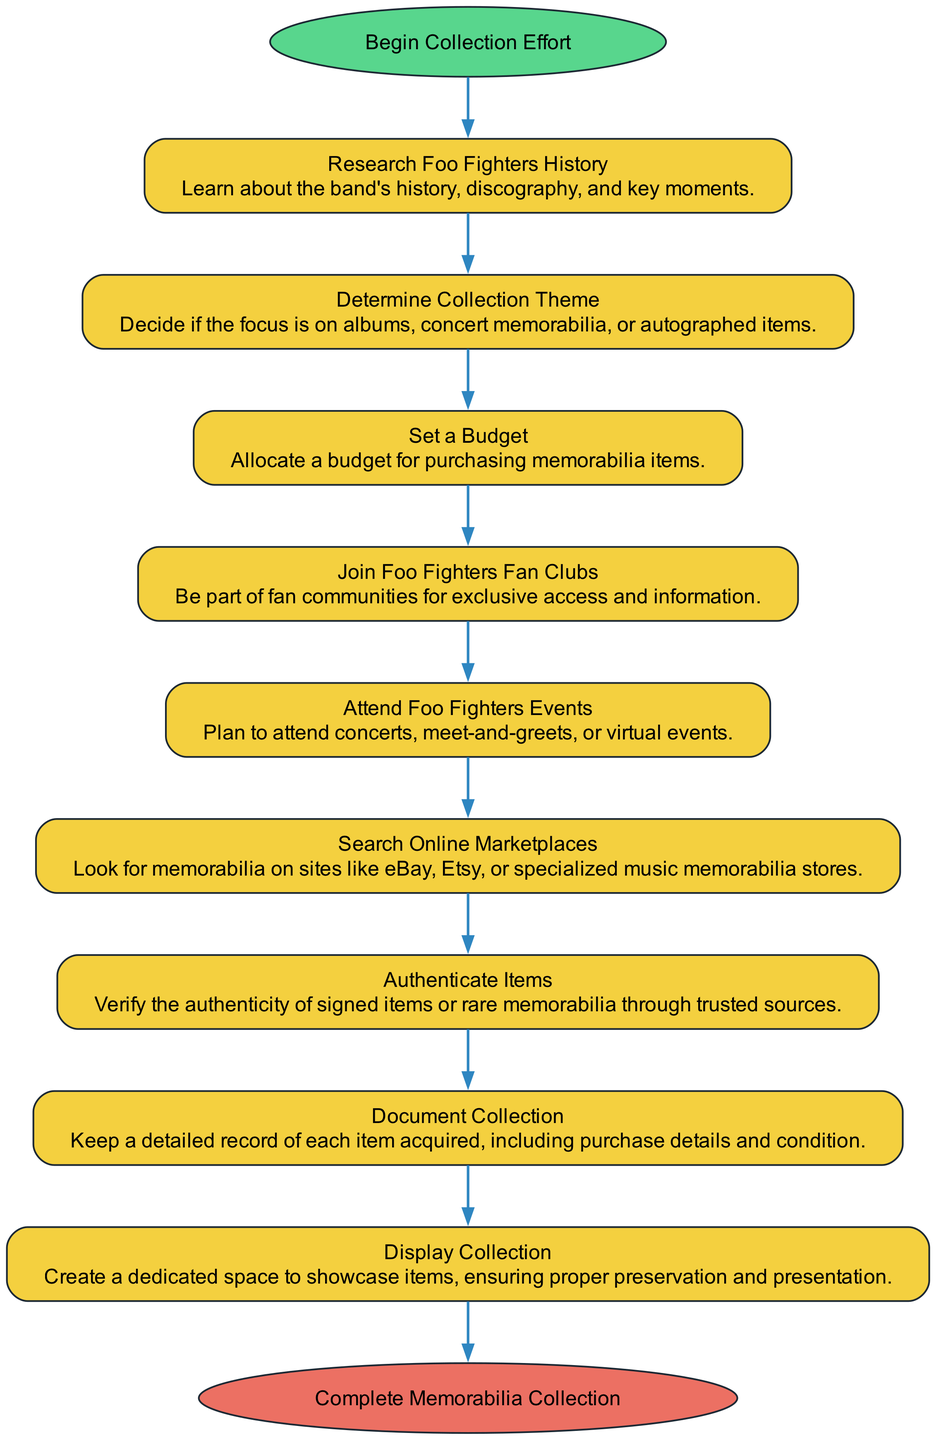What is the starting point of the collection effort? The diagram indicates that the starting point is "Begin Collection Effort". This is the first node in the flow of the activities, signifying where the process begins.
Answer: Begin Collection Effort How many activities are listed in the collection process? By counting the activities shown in the diagram, there are a total of nine activities listed that detail the steps involved.
Answer: 9 What activity comes after "Set a Budget"? Following the node for "Set a Budget," the next activity in the flow is "Join Foo Fighters Fan Clubs." This can be observed as the direct connection stemming from the budgeting activity.
Answer: Join Foo Fighters Fan Clubs Which activity is focused on verifying the authenticity of items? The activity that deals specifically with this task is "Authenticate Items." It is a key step that emphasizes the importance of ensuring the value of the collection.
Answer: Authenticate Items What is the final step in the memorabilia collection process? The last node in the flow concludes with "Complete Memorabilia Collection," marking the end of the effort to gather memorabilia.
Answer: Complete Memorabilia Collection How are the activities connected in the diagram? The activities are sequentially connected in a linear flow, where each step leads directly to the next, facilitating a clear progression toward completing the collection.
Answer: Sequentially What is the purpose of the activity "Document Collection"? The purpose of this activity is to maintain a detailed record of each collected item, which includes purchase specifics and item condition. This documentation aids in organizing and valuing the collection.
Answer: Keep detailed records What does the "Display Collection" activity involve? This activity involves creating a dedicated space where the collected items can be showcased properly, ensuring they are preserved and presented well for enjoyment and admiration.
Answer: Showcase items Which activity emphasizes participation in Foo Fighters events? The activity titled "Attend Foo Fighters Events" focuses on the importance of being present at various events related to Foo Fighters, enhancing the collection experience through direct engagement.
Answer: Attend Foo Fighters Events 